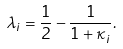Convert formula to latex. <formula><loc_0><loc_0><loc_500><loc_500>\lambda _ { i } = \frac { 1 } { 2 } - \frac { 1 } { 1 + \kappa _ { i } } .</formula> 